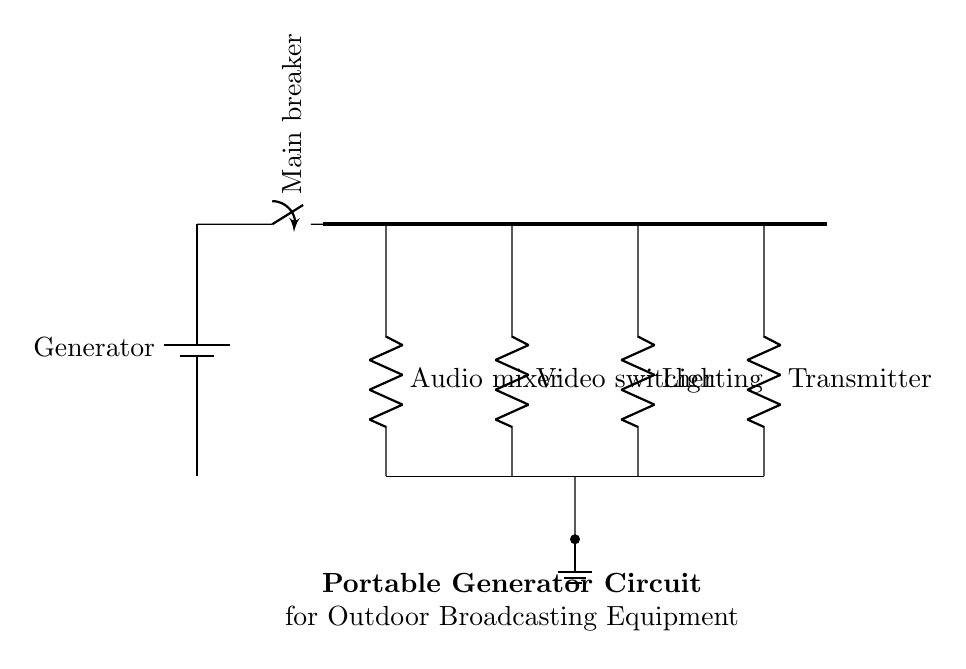What is the primary power source in this circuit? The primary power source is a generator, as indicated by the component labeled "Generator" connected to the circuit.
Answer: Generator What types of audio and video equipment does this circuit supply power to? The circuit supplies power to an audio mixer and a video switcher, which are specifically labeled in the diagram showing their individual connections.
Answer: Audio mixer and video switcher How many devices are connected in series to the bus bar? There are four devices connected in series to the bus bar: an audio mixer, a video switcher, lighting, and a transmitter. Each of these components is connected along the same pathway from the bus bar.
Answer: Four What function does the main breaker serve in this circuit? The main breaker's function is to control the flow of electricity from the generator to the rest of the circuit, allowing for safe operation by acting as a switch.
Answer: Control What is the purpose of the ground connection in the circuit? The ground connection serves to safely dissipate any excess electrical energy, protecting the equipment and users from potential overvoltage or faults. It's indicated by the connection to the ground symbol at the bottom of the circuit.
Answer: Safety Which component could be considered the last stage of the circuit before transmission? The component that acts as the last stage before transmission is the transmitter, as it takes the processed audio and video signals from the equipment and prepares them for broadcasting.
Answer: Transmitter 